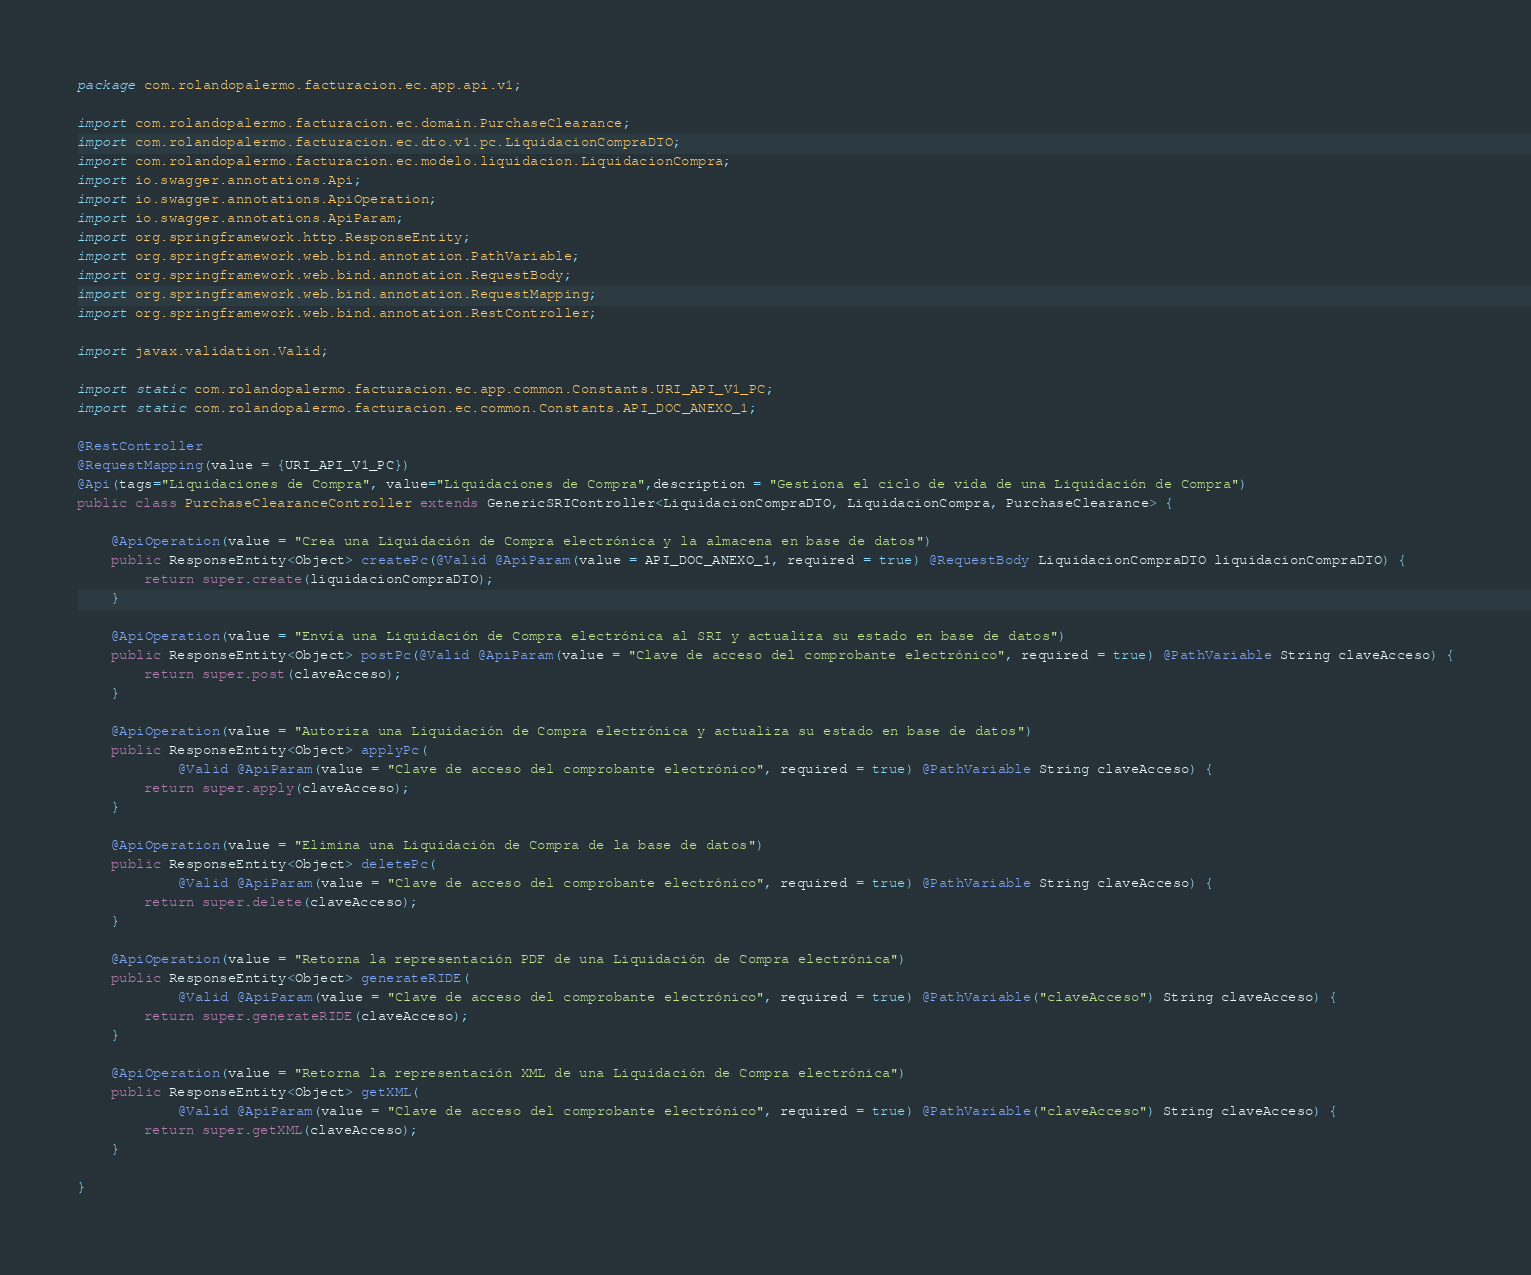Convert code to text. <code><loc_0><loc_0><loc_500><loc_500><_Java_>package com.rolandopalermo.facturacion.ec.app.api.v1;

import com.rolandopalermo.facturacion.ec.domain.PurchaseClearance;
import com.rolandopalermo.facturacion.ec.dto.v1.pc.LiquidacionCompraDTO;
import com.rolandopalermo.facturacion.ec.modelo.liquidacion.LiquidacionCompra;
import io.swagger.annotations.Api;
import io.swagger.annotations.ApiOperation;
import io.swagger.annotations.ApiParam;
import org.springframework.http.ResponseEntity;
import org.springframework.web.bind.annotation.PathVariable;
import org.springframework.web.bind.annotation.RequestBody;
import org.springframework.web.bind.annotation.RequestMapping;
import org.springframework.web.bind.annotation.RestController;

import javax.validation.Valid;

import static com.rolandopalermo.facturacion.ec.app.common.Constants.URI_API_V1_PC;
import static com.rolandopalermo.facturacion.ec.common.Constants.API_DOC_ANEXO_1;

@RestController
@RequestMapping(value = {URI_API_V1_PC})
@Api(tags="Liquidaciones de Compra", value="Liquidaciones de Compra",description = "Gestiona el ciclo de vida de una Liquidación de Compra")
public class PurchaseClearanceController extends GenericSRIController<LiquidacionCompraDTO, LiquidacionCompra, PurchaseClearance> {

    @ApiOperation(value = "Crea una Liquidación de Compra electrónica y la almacena en base de datos")
    public ResponseEntity<Object> createPc(@Valid @ApiParam(value = API_DOC_ANEXO_1, required = true) @RequestBody LiquidacionCompraDTO liquidacionCompraDTO) {
        return super.create(liquidacionCompraDTO);
    }

    @ApiOperation(value = "Envía una Liquidación de Compra electrónica al SRI y actualiza su estado en base de datos")
    public ResponseEntity<Object> postPc(@Valid @ApiParam(value = "Clave de acceso del comprobante electrónico", required = true) @PathVariable String claveAcceso) {
        return super.post(claveAcceso);
    }

    @ApiOperation(value = "Autoriza una Liquidación de Compra electrónica y actualiza su estado en base de datos")
    public ResponseEntity<Object> applyPc(
            @Valid @ApiParam(value = "Clave de acceso del comprobante electrónico", required = true) @PathVariable String claveAcceso) {
        return super.apply(claveAcceso);
    }

    @ApiOperation(value = "Elimina una Liquidación de Compra de la base de datos")
    public ResponseEntity<Object> deletePc(
            @Valid @ApiParam(value = "Clave de acceso del comprobante electrónico", required = true) @PathVariable String claveAcceso) {
        return super.delete(claveAcceso);
    }

    @ApiOperation(value = "Retorna la representación PDF de una Liquidación de Compra electrónica")
    public ResponseEntity<Object> generateRIDE(
            @Valid @ApiParam(value = "Clave de acceso del comprobante electrónico", required = true) @PathVariable("claveAcceso") String claveAcceso) {
        return super.generateRIDE(claveAcceso);
    }

    @ApiOperation(value = "Retorna la representación XML de una Liquidación de Compra electrónica")
    public ResponseEntity<Object> getXML(
            @Valid @ApiParam(value = "Clave de acceso del comprobante electrónico", required = true) @PathVariable("claveAcceso") String claveAcceso) {
        return super.getXML(claveAcceso);
    }

}</code> 